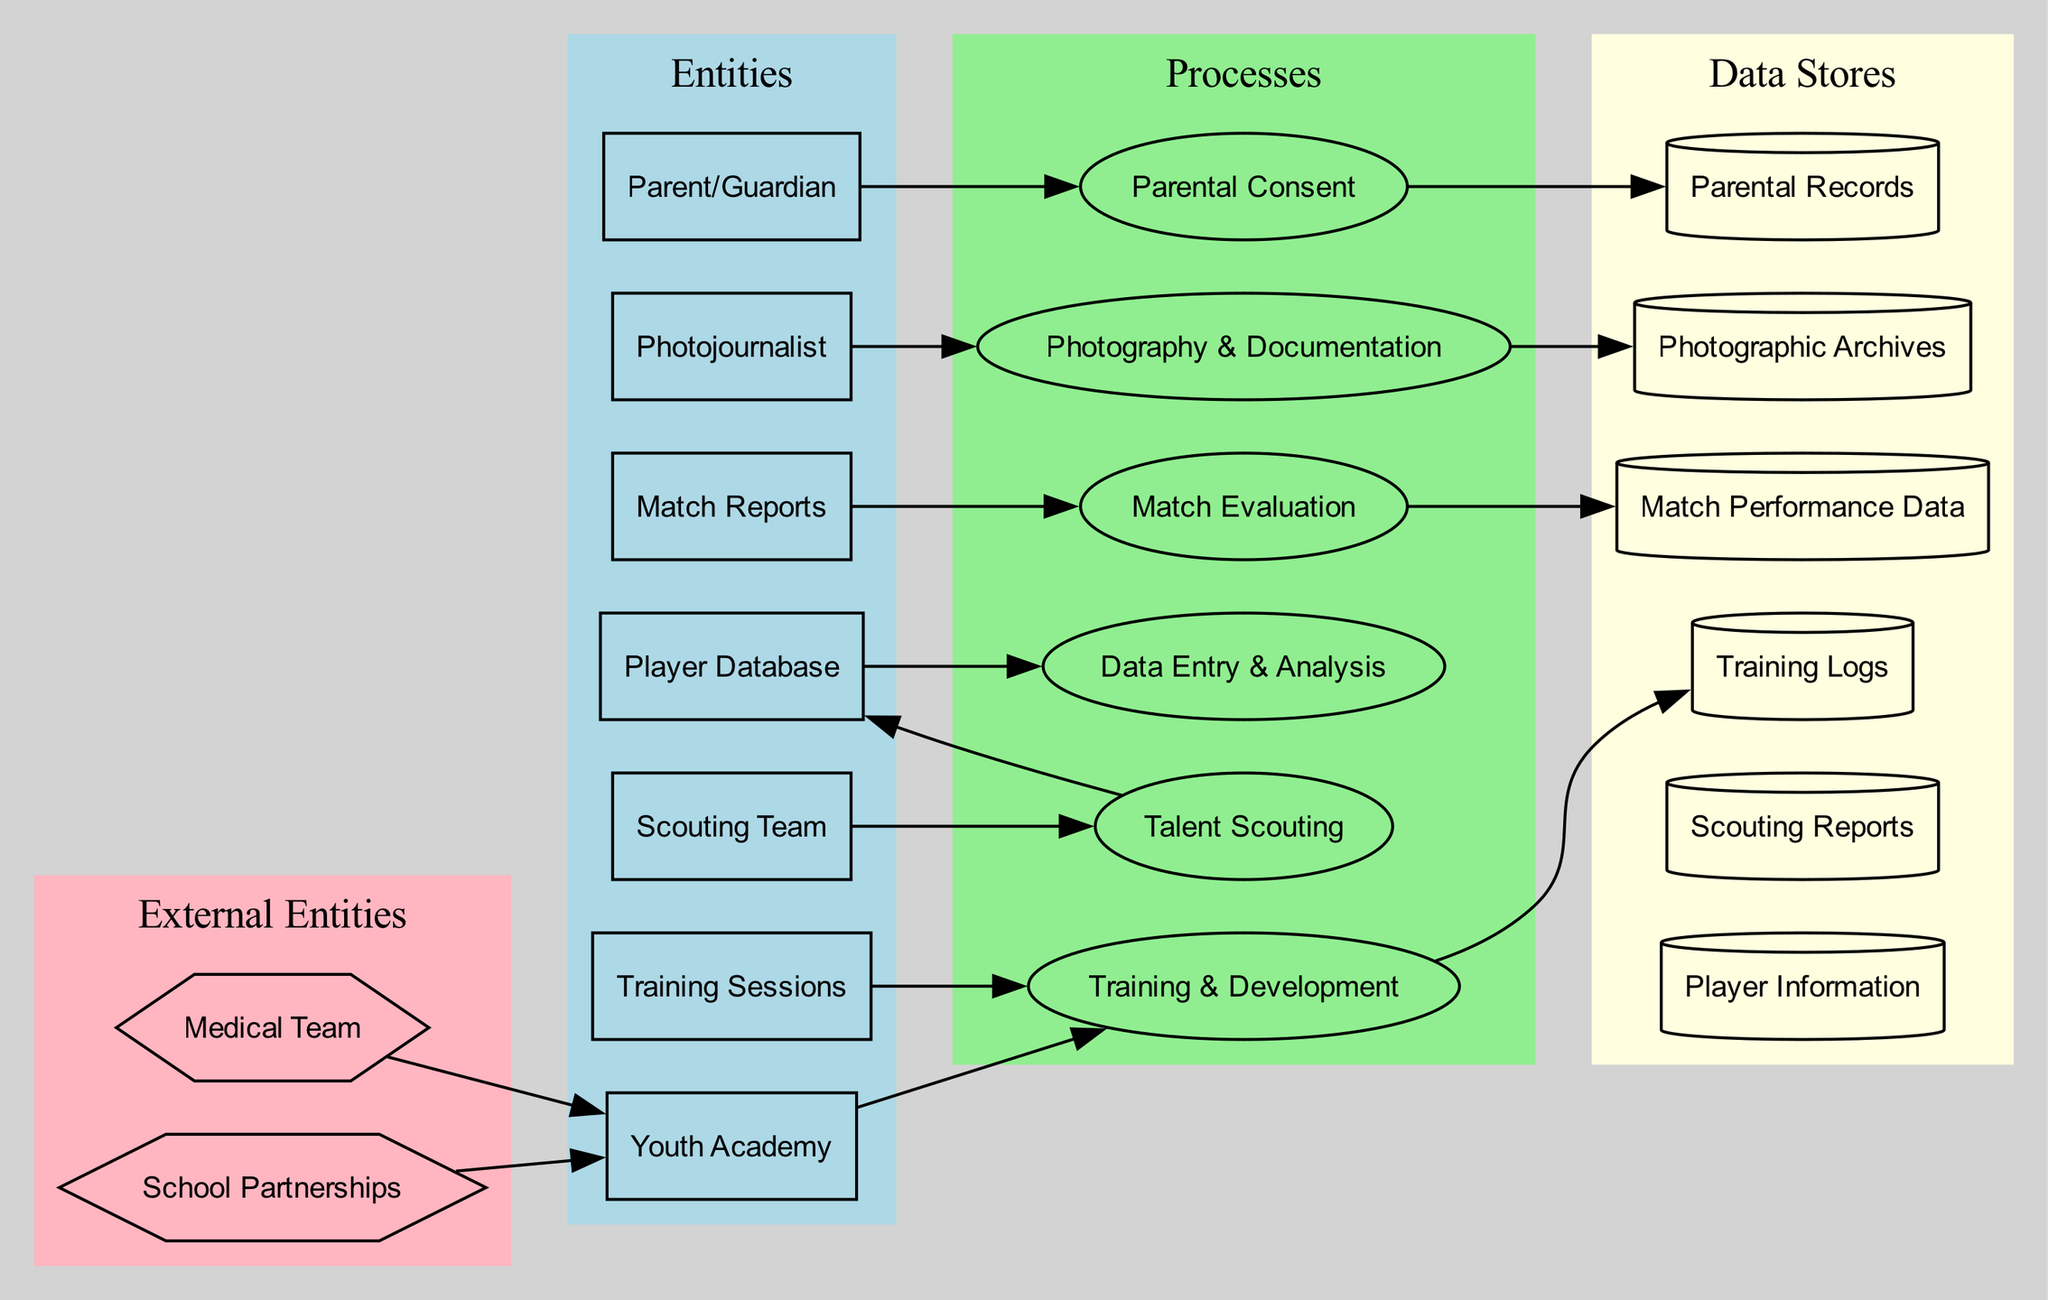What is the role of the Youth Academy? The Youth Academy is described as the central academy responsible for training and nurturing young talents. This indicates its primary function within the diagram.
Answer: Central academy responsible for training and nurturing young talents How many data stores are present in the diagram? By counting, there are a total of six data stores listed: Player Information, Scouting Reports, Training Logs, Match Performance Data, Photographic Archives, and Parental Records.
Answer: Six Which external entity collaborates with the academy? The diagram presents School Partnerships as the external entity that collaborates with the academy to provide additional opportunities and support for young players.
Answer: School Partnerships What process is connected to the Scouting Team? The edge shows that the Scouting Team is connected to the process of Talent Scouting. This indicates that the Scouting Team participates in this specific process.
Answer: Talent Scouting What data store contains performance metrics of players? The Player Information data store contains details about individual players, including performance metrics which are essential for assessing their development.
Answer: Player Information How many connections lead from the Talent Scouting process? There are two outgoing connections from the Talent Scouting process: one to the Player Database and another leading into the Data Entry & Analysis process, indicating its influence on data handling.
Answer: Two What type of documentation does the Photojournalist handle? The Photojournalist is responsible for Photography & Documentation, which includes capturing important moments during training sessions and matches. This is indicated by the process connected to this entity.
Answer: Photography & Documentation Which process involves evaluating player performances during matches? The diagram specifies that Match Evaluation is the process that involves evaluating player performances, suggesting it is linked to the review of match reports.
Answer: Match Evaluation What is the function of the Medical Team in relation to the Youth Academy? The Medical Team provides medical support and fitness assessments for the players, as indicated by the edge connecting them to the Youth Academy.
Answer: Medical support and fitness assessments 